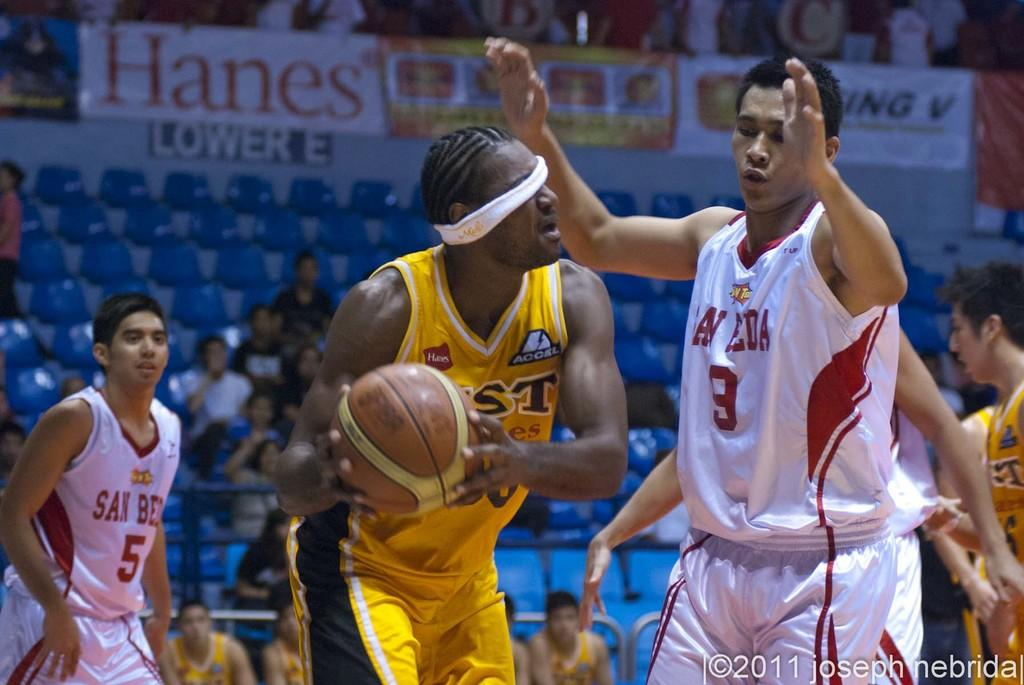<image>
Render a clear and concise summary of the photo. Number 9 tries to keep his opponent from passing the ball accurately. 